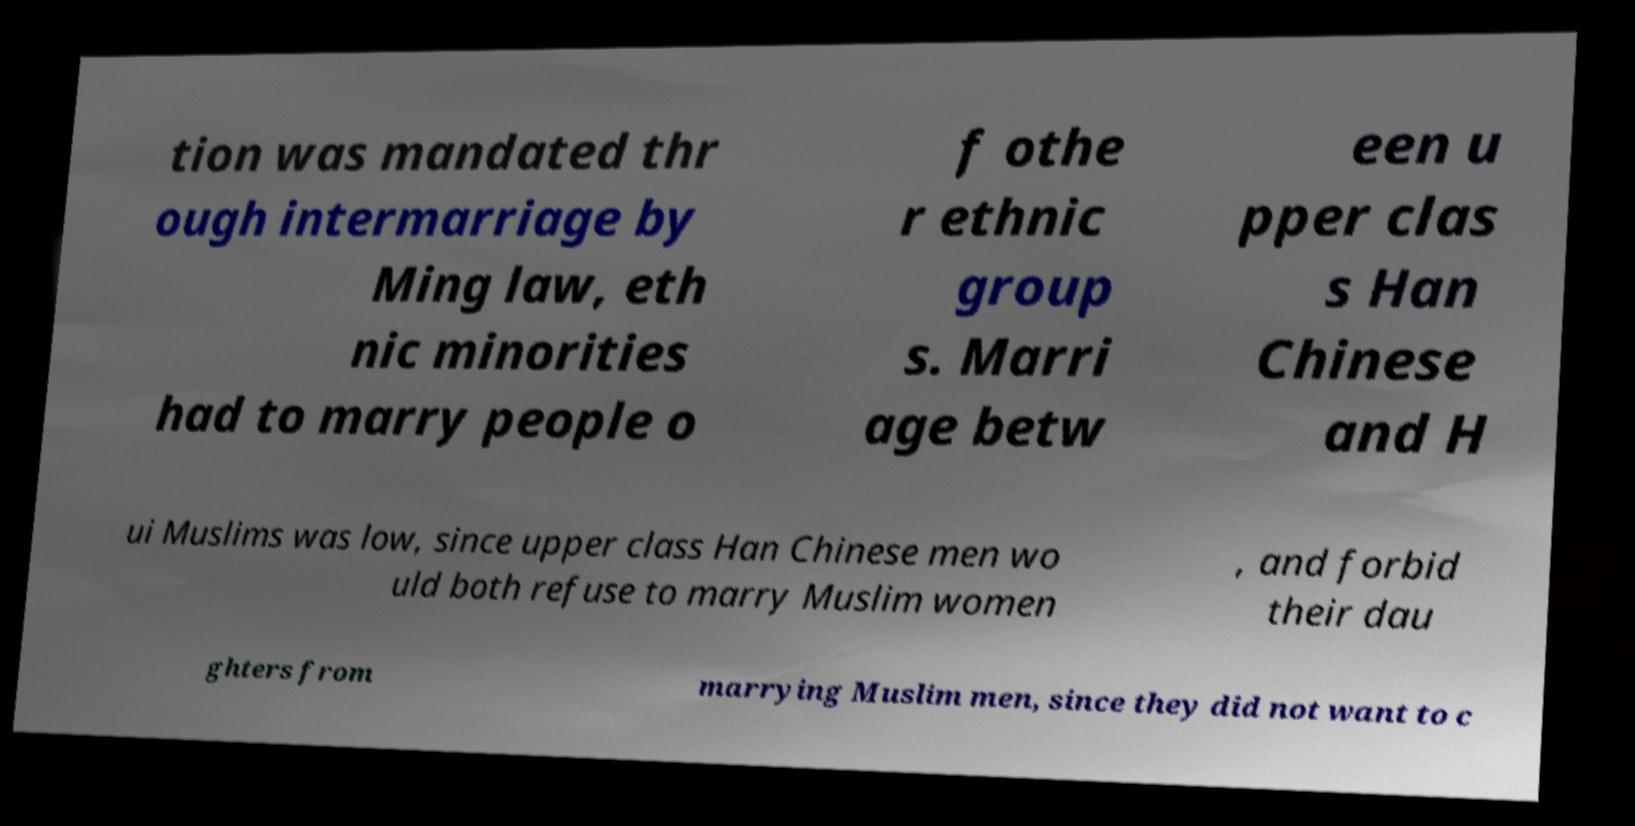There's text embedded in this image that I need extracted. Can you transcribe it verbatim? tion was mandated thr ough intermarriage by Ming law, eth nic minorities had to marry people o f othe r ethnic group s. Marri age betw een u pper clas s Han Chinese and H ui Muslims was low, since upper class Han Chinese men wo uld both refuse to marry Muslim women , and forbid their dau ghters from marrying Muslim men, since they did not want to c 